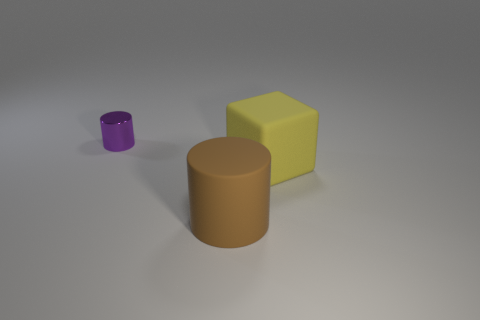Add 3 large matte objects. How many objects exist? 6 Subtract all cylinders. How many objects are left? 1 Subtract 1 purple cylinders. How many objects are left? 2 Subtract all large gray metal things. Subtract all brown cylinders. How many objects are left? 2 Add 3 matte things. How many matte things are left? 5 Add 1 large blue metal objects. How many large blue metal objects exist? 1 